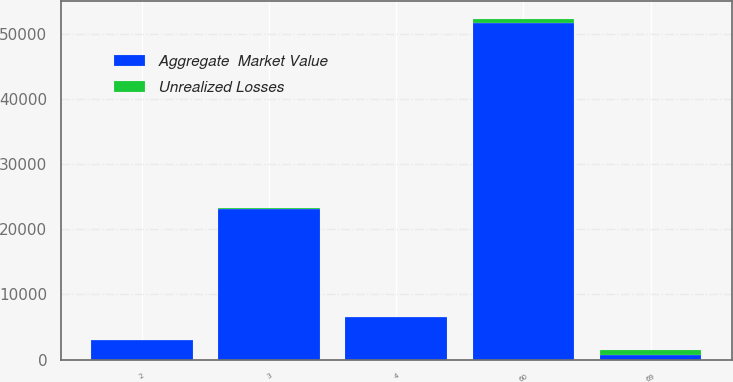Convert chart to OTSL. <chart><loc_0><loc_0><loc_500><loc_500><stacked_bar_chart><ecel><fcel>3<fcel>4<fcel>60<fcel>2<fcel>69<nl><fcel>Aggregate  Market Value<fcel>23207<fcel>6559<fcel>51757<fcel>2982<fcel>713<nl><fcel>Unrealized Losses<fcel>19<fcel>20<fcel>673<fcel>1<fcel>713<nl></chart> 